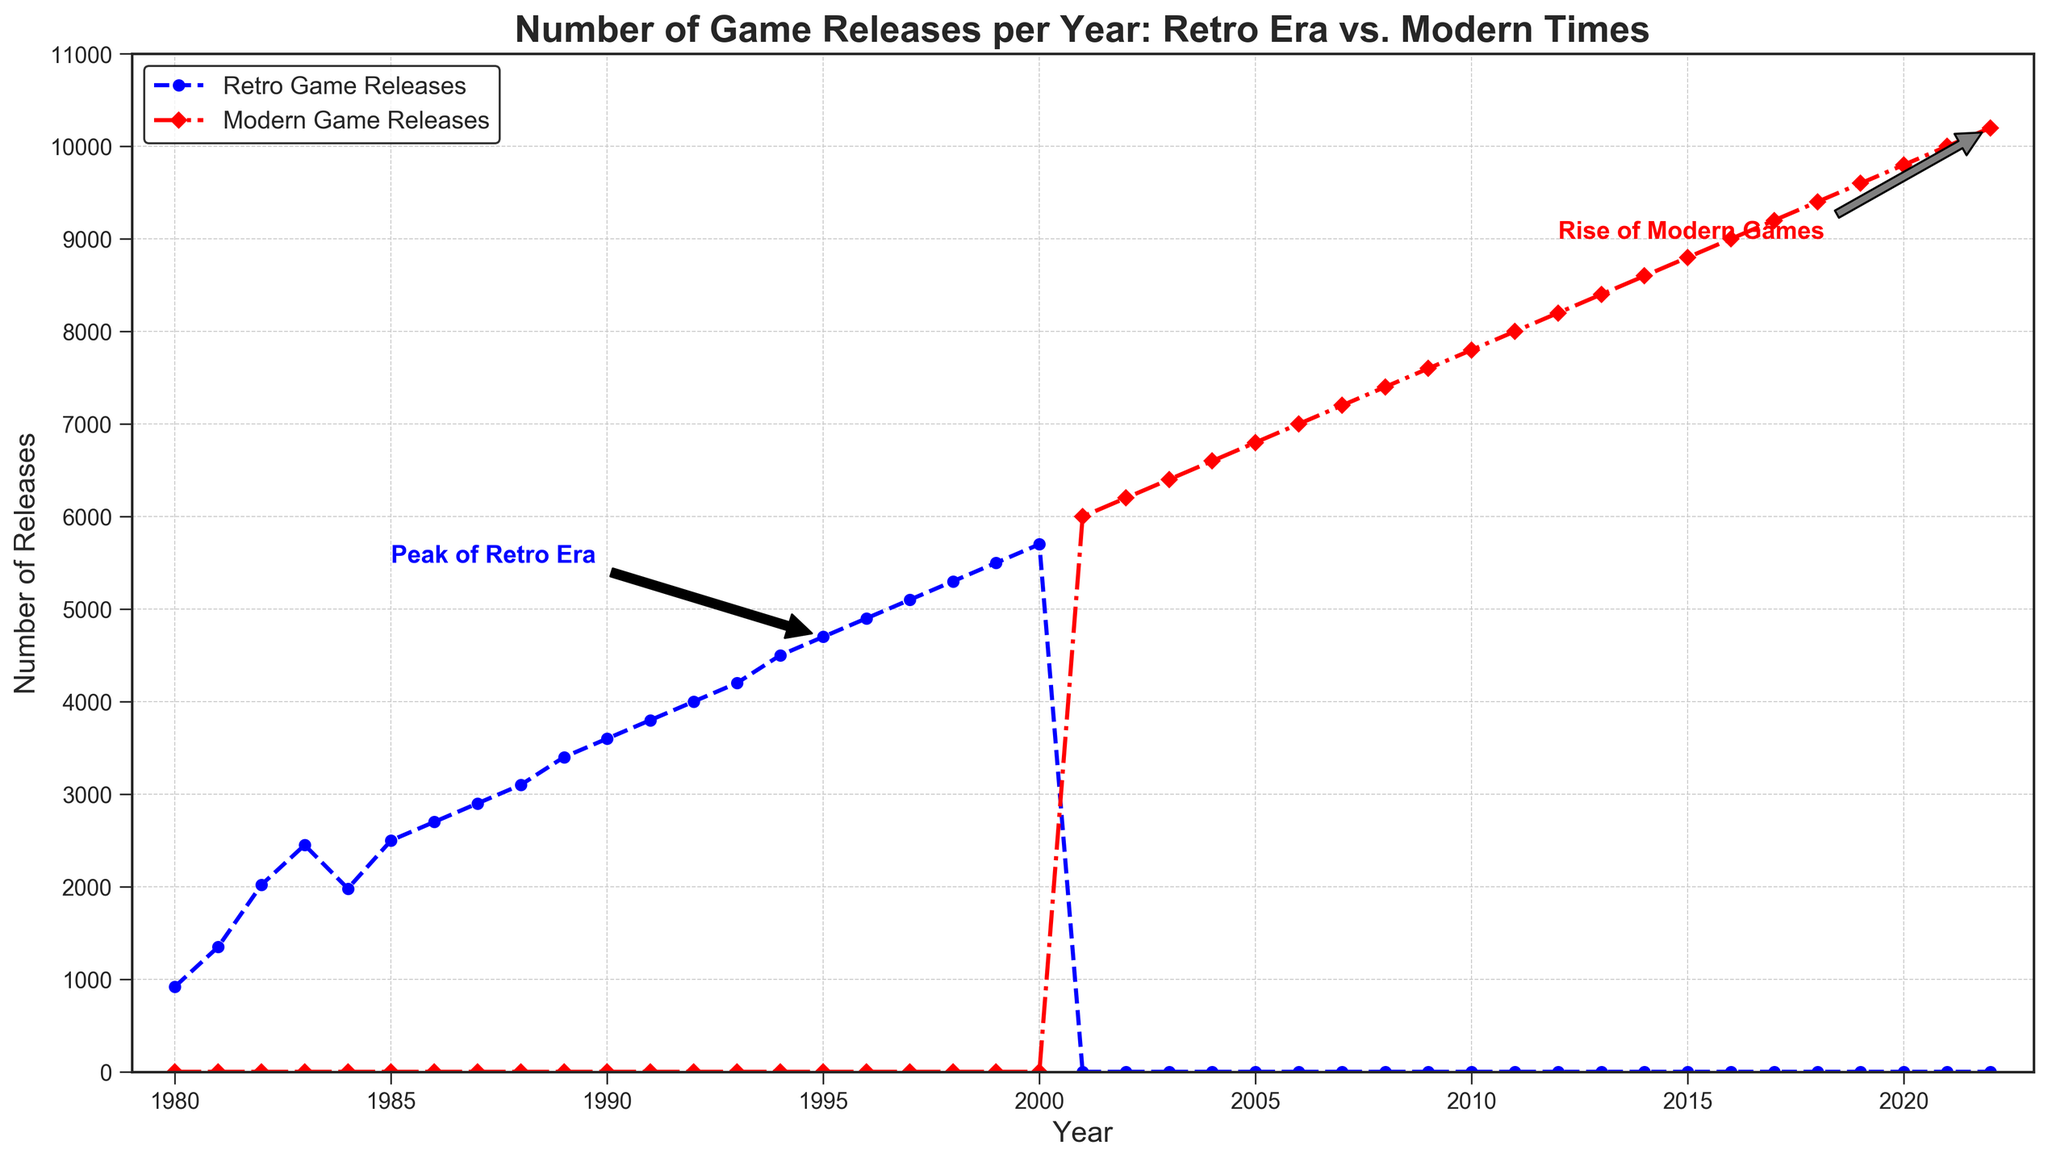What is the highest number of retro game releases in a single year? The highest number of retro game releases is in the year 2000 with 5,700 releases. You can see this from the upper limit of the blue line in the chart.
Answer: 5,700 In which year did retro game releases peak before entering the modern game releases era? The retro game releases peaked in the year 1995 with 4,700 releases, as indicated by the annotation "Peak of Retro Era."
Answer: 1995 How do the number of game releases in 1985 compare to those in 2000? In 1985, there were 2,500 retro game releases, and in 2000, there were 5,700 retro game releases. Comparing these two values shows a significant increase in the number of retro game releases over these years.
Answer: 1985: 2,500; 2000: 5,700 What trend in game releases is highlighted by the "Rise of Modern Games" annotation? The "Rise of Modern Games" annotation is highlighting the consistent increase in the number of modern game releases from around 2012 to 2022, culminating in 10,200 game releases in 2022.
Answer: Consistent increase Between which years is there a transition from retro to modern game releases? The transition from retro game releases to modern game releases occurs between 2000 and 2001, where retro game releases drop to zero, and modern game releases start.
Answer: 2000-2001 What is the number of modern game releases in the year 2010? Looking at the red line for modern game releases, there are 7,800 modern game releases in the year 2010.
Answer: 7,800 How does the number of releases in the peak year of retro games compare to the number of releases in the peak year of modern games? The peak year for retro games is 1995 with 4,700 releases, while for modern games, the peak year is 2022 with 10,200 releases. The number of modern game releases in 2022 is significantly higher than the number of retro game releases in 1995.
Answer: Retro: 4,700; Modern: 10,200 What is the average number of game releases per year during the retro era from 1980 to 2000? Sum all the retro game releases from 1980 to 2000 and divide by the number of years: (920 + 1350 + 2020 + 2450 + 1980 + 2500 + 2700 + 2900 + 3100 + 3400 + 3600 + 3800 + 4000 + 4200 + 4500 + 4700 + 4900 + 5100 + 5300 + 5500 + 5700) / 21 = 3,295.24.
Answer: 3,295.24 What is the difference in the number of game releases between 2015 and 2020 for modern games? For modern games, there were 8,800 releases in 2015 and 9,800 releases in 2020. The difference between these releases is 9,800 - 8,800 = 1,000.
Answer: 1,000 Is there ever a point where retro game releases are higher than modern game releases after 2000? No, after 2000, retro game releases are zero, and modern game releases start and increase, so there is no point where retro game releases are higher than modern game releases after 2000.
Answer: No 